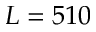<formula> <loc_0><loc_0><loc_500><loc_500>L = 5 1 0</formula> 